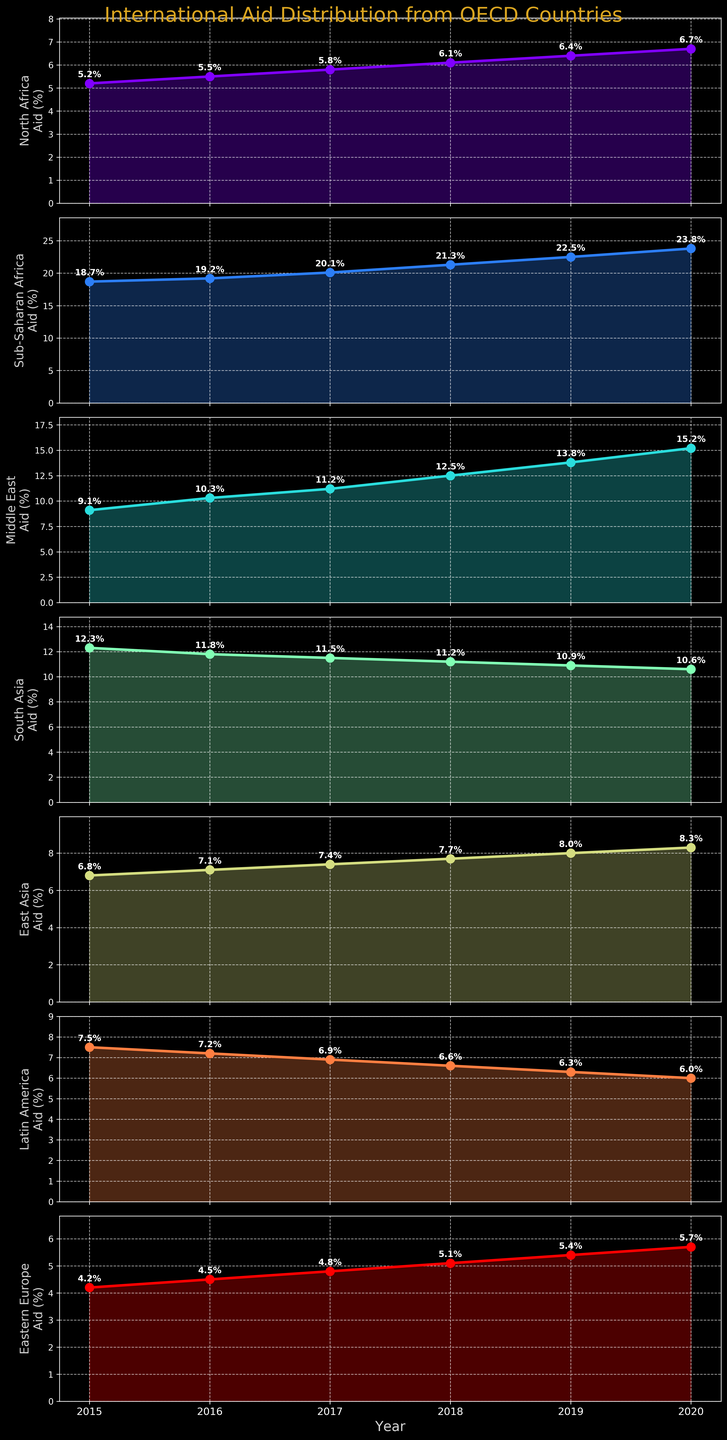Which region received the highest percentage of aid in 2020? The subplot for each region shows the aid received each year as a line with markers. By examining the subplots, we see that Sub-Saharan Africa received the highest percentage in 2020, reaching 23.8%.
Answer: Sub-Saharan Africa What is the trend of aid percentage for South Asia from 2015 to 2020? The subplot for South Asia shows the year on the x-axis and aid percentage on the y-axis. The overall trend for South Asia shows a decline from 12.3% in 2015 to 10.6% in 2020.
Answer: Declining Compare the aid percentage trends between Middle East and Eastern Europe from 2015 to 2020. By observing both subplots, the Middle East shows an increasing trend in aid percentage from 9.1% to 15.2%, while Eastern Europe also shows an increase but from a lower base, moving from 4.2% to 5.7%.
Answer: Both increasing, Middle East more steeply Which region had the smallest change in aid percentage from 2015 to 2020? To determine this, calculate the difference in aid percentage for each region from 2015 to 2020. The region with the smallest difference is Eastern Europe, changing from 4.2% to 5.7%, a difference of 1.5%.
Answer: Eastern Europe How did the aid given to North Africa change over the years? The subplot for North Africa shows a year-by-year increase in the aid percentage, from 5.2% in 2015 to 6.7% in 2020.
Answer: Increasing What is the average aid percentage to East Asia over the six years? Calculate the sum of the aid percentages for East Asia from 2015 to 2020 (6.8 + 7.1 + 7.4 + 7.7 + 8.0 + 8.3) and divide by 6. The total sum is 45.3, so the average is 45.3 / 6 = 7.55%.
Answer: 7.55% Which two regions show the most contrasting trends in aid received? By comparing all subplots, the most contrasting trends appear between Sub-Saharan Africa (steadily increasing) and South Asia (steadily decreasing).
Answer: Sub-Saharan Africa and South Asia What is the combined aid percentage of North Africa and Latin America in 2018? In 2018, the aid percentage for North Africa is 6.1% and for Latin America is 6.6%. Adding these gives 6.1% + 6.6% = 12.7%.
Answer: 12.7% How many regions saw an increase in aid percentage every year from 2015 to 2020? By examining the subplots for all regions, observe which ones consistently increased each year. These regions are North Africa, Sub-Saharan Africa, Middle East, and Eastern Europe—totaling four regions.
Answer: 4 Identify the year with the highest combined aid percentage across all regions. Sum the aid percentages for each year and compare. For 2015-2020, the sums are:
2015: 63.8%
2016: 65.6%
2017: 66.8%
2018: 70.5%
2019: 72.3%
2020: 76.3%
The highest combined percentage appears in 2020.
Answer: 2020 